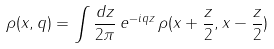<formula> <loc_0><loc_0><loc_500><loc_500>\rho ( x , q ) = \int { \frac { d z } { 2 \pi } \, e ^ { - i q z } \, \rho ( x + \frac { z } { 2 } , x - \frac { z } { 2 } ) }</formula> 